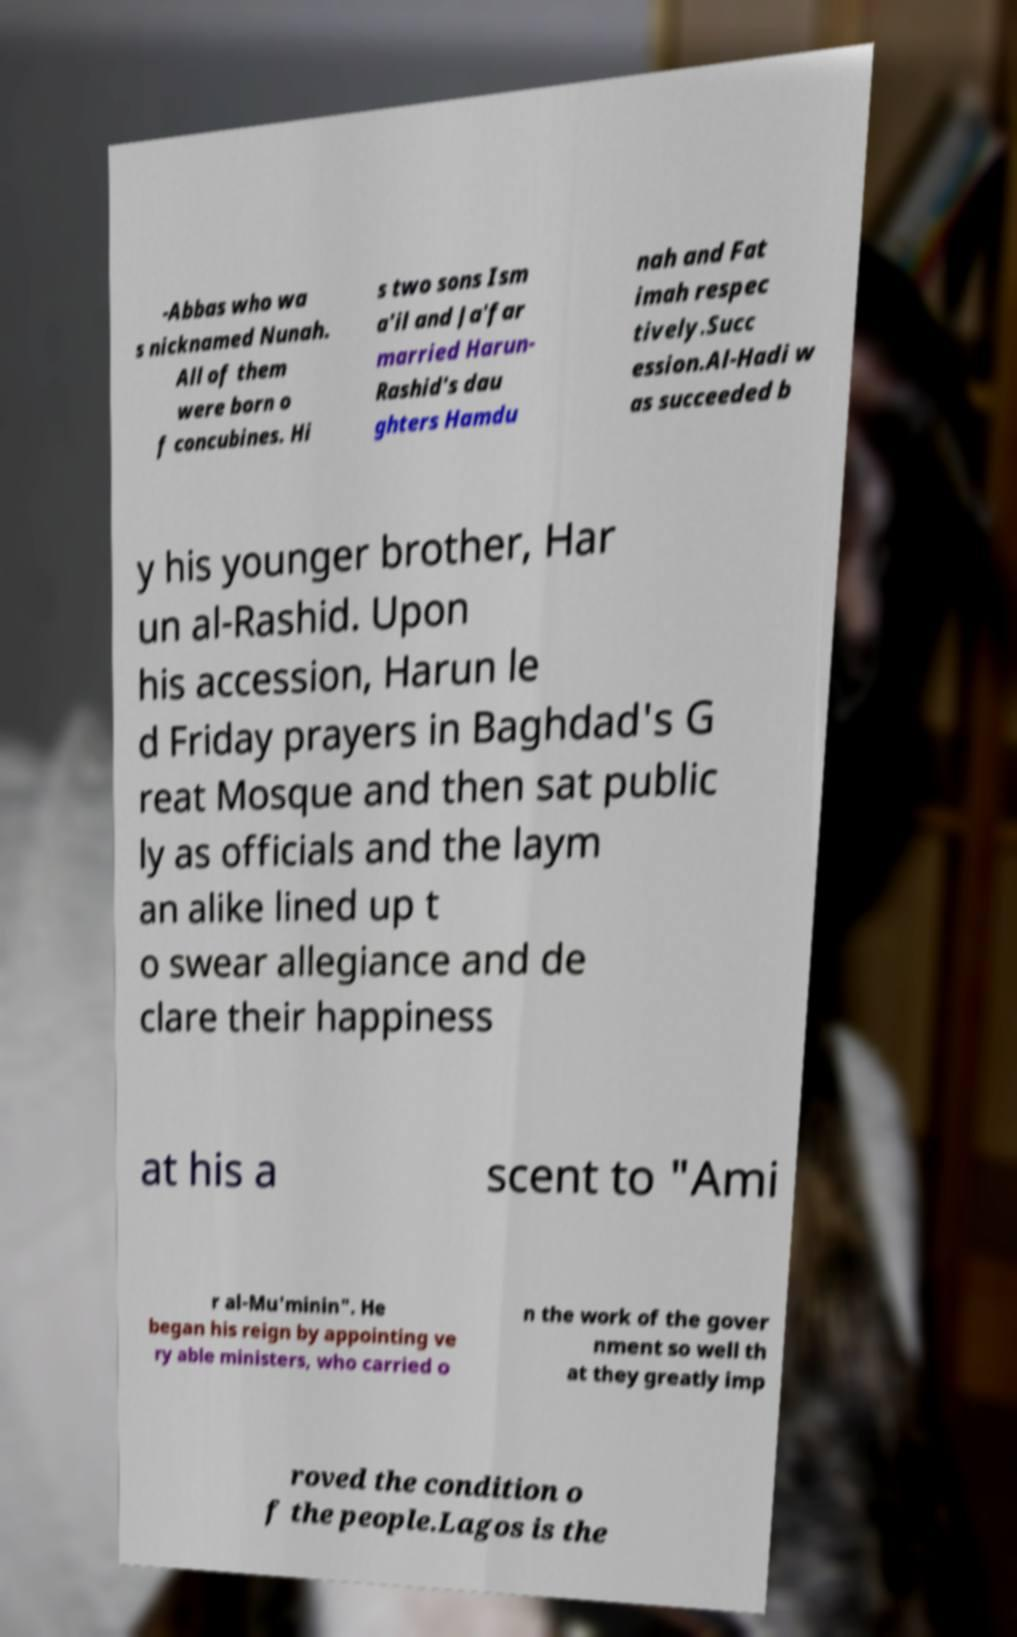What messages or text are displayed in this image? I need them in a readable, typed format. -Abbas who wa s nicknamed Nunah. All of them were born o f concubines. Hi s two sons Ism a'il and Ja'far married Harun- Rashid's dau ghters Hamdu nah and Fat imah respec tively.Succ ession.Al-Hadi w as succeeded b y his younger brother, Har un al-Rashid. Upon his accession, Harun le d Friday prayers in Baghdad's G reat Mosque and then sat public ly as officials and the laym an alike lined up t o swear allegiance and de clare their happiness at his a scent to "Ami r al-Mu'minin". He began his reign by appointing ve ry able ministers, who carried o n the work of the gover nment so well th at they greatly imp roved the condition o f the people.Lagos is the 